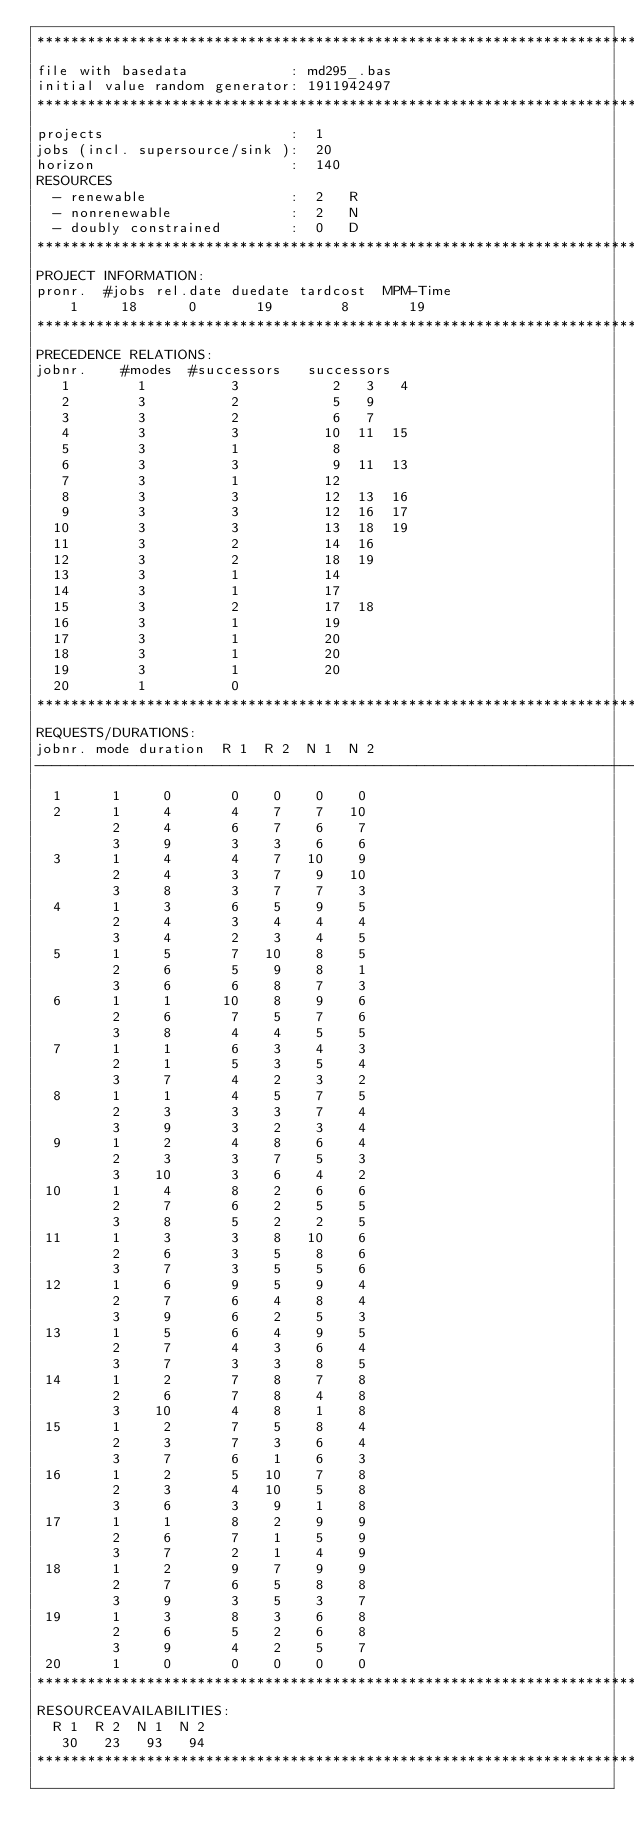<code> <loc_0><loc_0><loc_500><loc_500><_ObjectiveC_>************************************************************************
file with basedata            : md295_.bas
initial value random generator: 1911942497
************************************************************************
projects                      :  1
jobs (incl. supersource/sink ):  20
horizon                       :  140
RESOURCES
  - renewable                 :  2   R
  - nonrenewable              :  2   N
  - doubly constrained        :  0   D
************************************************************************
PROJECT INFORMATION:
pronr.  #jobs rel.date duedate tardcost  MPM-Time
    1     18      0       19        8       19
************************************************************************
PRECEDENCE RELATIONS:
jobnr.    #modes  #successors   successors
   1        1          3           2   3   4
   2        3          2           5   9
   3        3          2           6   7
   4        3          3          10  11  15
   5        3          1           8
   6        3          3           9  11  13
   7        3          1          12
   8        3          3          12  13  16
   9        3          3          12  16  17
  10        3          3          13  18  19
  11        3          2          14  16
  12        3          2          18  19
  13        3          1          14
  14        3          1          17
  15        3          2          17  18
  16        3          1          19
  17        3          1          20
  18        3          1          20
  19        3          1          20
  20        1          0        
************************************************************************
REQUESTS/DURATIONS:
jobnr. mode duration  R 1  R 2  N 1  N 2
------------------------------------------------------------------------
  1      1     0       0    0    0    0
  2      1     4       4    7    7   10
         2     4       6    7    6    7
         3     9       3    3    6    6
  3      1     4       4    7   10    9
         2     4       3    7    9   10
         3     8       3    7    7    3
  4      1     3       6    5    9    5
         2     4       3    4    4    4
         3     4       2    3    4    5
  5      1     5       7   10    8    5
         2     6       5    9    8    1
         3     6       6    8    7    3
  6      1     1      10    8    9    6
         2     6       7    5    7    6
         3     8       4    4    5    5
  7      1     1       6    3    4    3
         2     1       5    3    5    4
         3     7       4    2    3    2
  8      1     1       4    5    7    5
         2     3       3    3    7    4
         3     9       3    2    3    4
  9      1     2       4    8    6    4
         2     3       3    7    5    3
         3    10       3    6    4    2
 10      1     4       8    2    6    6
         2     7       6    2    5    5
         3     8       5    2    2    5
 11      1     3       3    8   10    6
         2     6       3    5    8    6
         3     7       3    5    5    6
 12      1     6       9    5    9    4
         2     7       6    4    8    4
         3     9       6    2    5    3
 13      1     5       6    4    9    5
         2     7       4    3    6    4
         3     7       3    3    8    5
 14      1     2       7    8    7    8
         2     6       7    8    4    8
         3    10       4    8    1    8
 15      1     2       7    5    8    4
         2     3       7    3    6    4
         3     7       6    1    6    3
 16      1     2       5   10    7    8
         2     3       4   10    5    8
         3     6       3    9    1    8
 17      1     1       8    2    9    9
         2     6       7    1    5    9
         3     7       2    1    4    9
 18      1     2       9    7    9    9
         2     7       6    5    8    8
         3     9       3    5    3    7
 19      1     3       8    3    6    8
         2     6       5    2    6    8
         3     9       4    2    5    7
 20      1     0       0    0    0    0
************************************************************************
RESOURCEAVAILABILITIES:
  R 1  R 2  N 1  N 2
   30   23   93   94
************************************************************************
</code> 